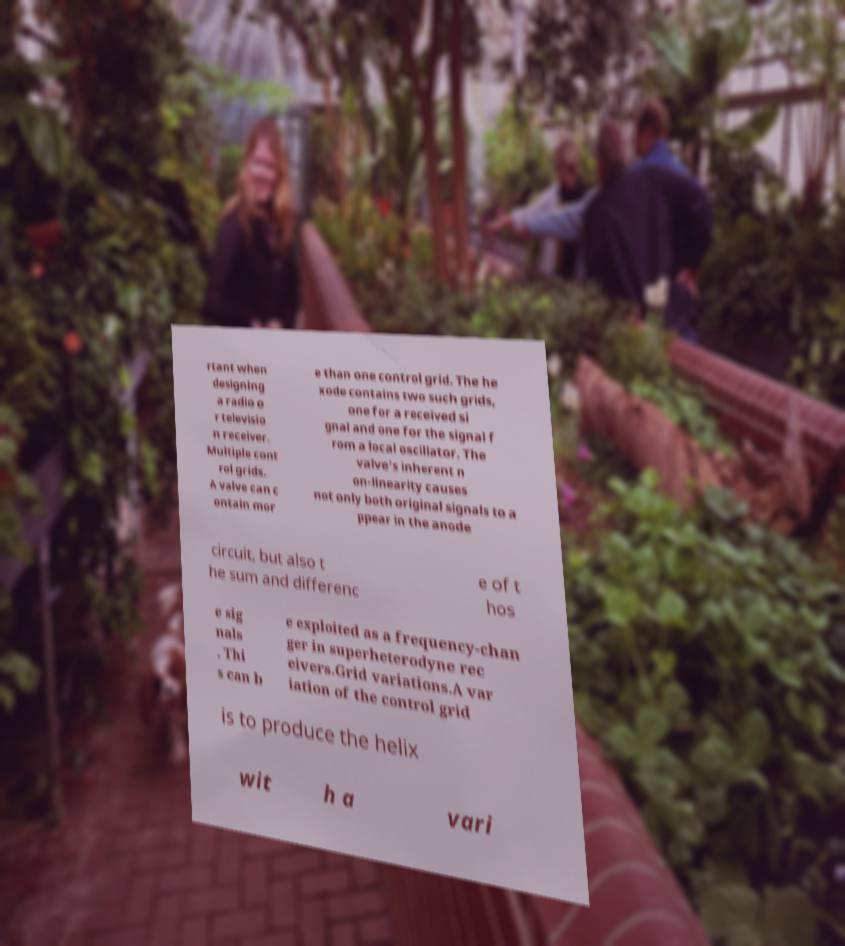What messages or text are displayed in this image? I need them in a readable, typed format. rtant when designing a radio o r televisio n receiver. Multiple cont rol grids. A valve can c ontain mor e than one control grid. The he xode contains two such grids, one for a received si gnal and one for the signal f rom a local oscillator. The valve's inherent n on-linearity causes not only both original signals to a ppear in the anode circuit, but also t he sum and differenc e of t hos e sig nals . Thi s can b e exploited as a frequency-chan ger in superheterodyne rec eivers.Grid variations.A var iation of the control grid is to produce the helix wit h a vari 